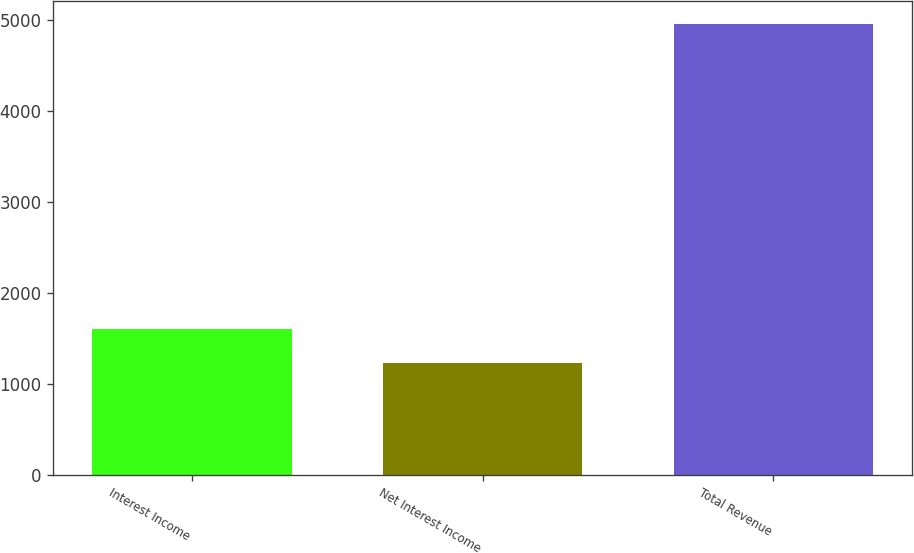<chart> <loc_0><loc_0><loc_500><loc_500><bar_chart><fcel>Interest Income<fcel>Net Interest Income<fcel>Total Revenue<nl><fcel>1607.59<fcel>1234.9<fcel>4961.8<nl></chart> 